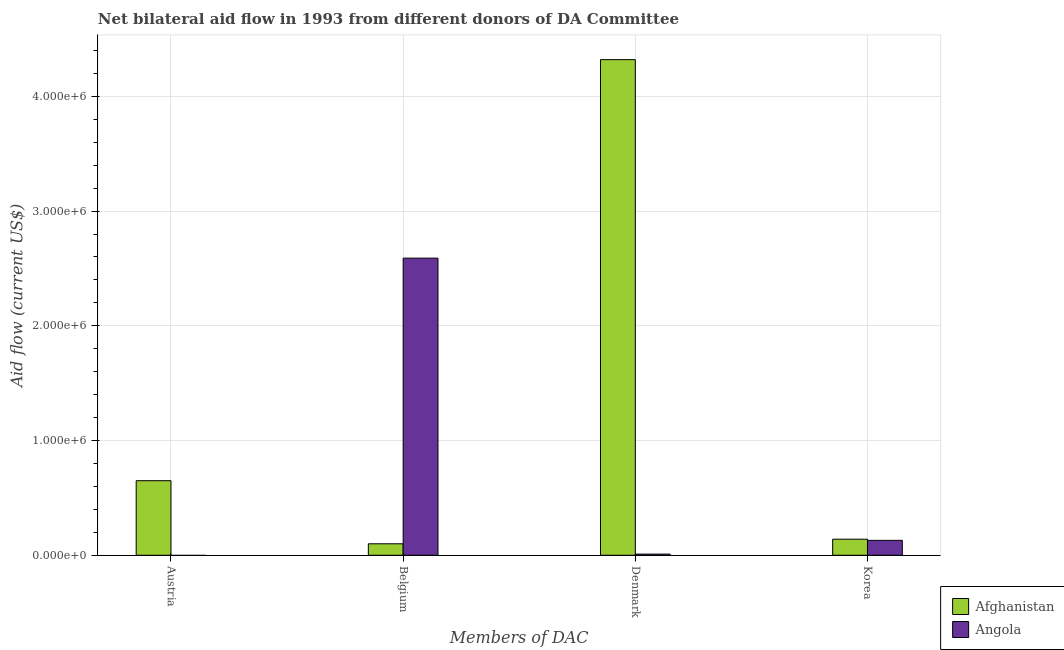How many different coloured bars are there?
Give a very brief answer. 2. Are the number of bars per tick equal to the number of legend labels?
Your answer should be very brief. No. How many bars are there on the 2nd tick from the right?
Offer a very short reply. 2. What is the label of the 3rd group of bars from the left?
Your answer should be compact. Denmark. What is the amount of aid given by belgium in Afghanistan?
Keep it short and to the point. 1.00e+05. Across all countries, what is the maximum amount of aid given by korea?
Provide a short and direct response. 1.40e+05. Across all countries, what is the minimum amount of aid given by belgium?
Make the answer very short. 1.00e+05. In which country was the amount of aid given by austria maximum?
Offer a terse response. Afghanistan. What is the total amount of aid given by belgium in the graph?
Provide a succinct answer. 2.69e+06. What is the difference between the amount of aid given by denmark in Angola and that in Afghanistan?
Your answer should be compact. -4.31e+06. What is the difference between the amount of aid given by denmark in Angola and the amount of aid given by belgium in Afghanistan?
Make the answer very short. -9.00e+04. What is the average amount of aid given by korea per country?
Offer a very short reply. 1.35e+05. What is the difference between the amount of aid given by belgium and amount of aid given by korea in Afghanistan?
Provide a short and direct response. -4.00e+04. What is the ratio of the amount of aid given by belgium in Afghanistan to that in Angola?
Offer a very short reply. 0.04. What is the difference between the highest and the second highest amount of aid given by denmark?
Ensure brevity in your answer.  4.31e+06. What is the difference between the highest and the lowest amount of aid given by denmark?
Offer a very short reply. 4.31e+06. In how many countries, is the amount of aid given by korea greater than the average amount of aid given by korea taken over all countries?
Offer a very short reply. 1. Is the sum of the amount of aid given by korea in Afghanistan and Angola greater than the maximum amount of aid given by belgium across all countries?
Provide a short and direct response. No. Is it the case that in every country, the sum of the amount of aid given by austria and amount of aid given by belgium is greater than the amount of aid given by denmark?
Your answer should be very brief. No. How many bars are there?
Your answer should be compact. 7. Are all the bars in the graph horizontal?
Your answer should be very brief. No. Does the graph contain grids?
Your answer should be very brief. Yes. Where does the legend appear in the graph?
Offer a very short reply. Bottom right. How many legend labels are there?
Give a very brief answer. 2. How are the legend labels stacked?
Your answer should be compact. Vertical. What is the title of the graph?
Give a very brief answer. Net bilateral aid flow in 1993 from different donors of DA Committee. Does "West Bank and Gaza" appear as one of the legend labels in the graph?
Provide a short and direct response. No. What is the label or title of the X-axis?
Make the answer very short. Members of DAC. What is the Aid flow (current US$) of Afghanistan in Austria?
Ensure brevity in your answer.  6.50e+05. What is the Aid flow (current US$) in Angola in Belgium?
Provide a succinct answer. 2.59e+06. What is the Aid flow (current US$) in Afghanistan in Denmark?
Provide a succinct answer. 4.32e+06. What is the Aid flow (current US$) of Angola in Denmark?
Offer a terse response. 10000. What is the Aid flow (current US$) in Afghanistan in Korea?
Provide a succinct answer. 1.40e+05. What is the Aid flow (current US$) of Angola in Korea?
Ensure brevity in your answer.  1.30e+05. Across all Members of DAC, what is the maximum Aid flow (current US$) of Afghanistan?
Offer a very short reply. 4.32e+06. Across all Members of DAC, what is the maximum Aid flow (current US$) of Angola?
Offer a very short reply. 2.59e+06. Across all Members of DAC, what is the minimum Aid flow (current US$) of Afghanistan?
Ensure brevity in your answer.  1.00e+05. Across all Members of DAC, what is the minimum Aid flow (current US$) of Angola?
Give a very brief answer. 0. What is the total Aid flow (current US$) of Afghanistan in the graph?
Offer a terse response. 5.21e+06. What is the total Aid flow (current US$) in Angola in the graph?
Your response must be concise. 2.73e+06. What is the difference between the Aid flow (current US$) of Afghanistan in Austria and that in Denmark?
Your answer should be compact. -3.67e+06. What is the difference between the Aid flow (current US$) in Afghanistan in Austria and that in Korea?
Your answer should be very brief. 5.10e+05. What is the difference between the Aid flow (current US$) in Afghanistan in Belgium and that in Denmark?
Offer a very short reply. -4.22e+06. What is the difference between the Aid flow (current US$) in Angola in Belgium and that in Denmark?
Your answer should be compact. 2.58e+06. What is the difference between the Aid flow (current US$) of Afghanistan in Belgium and that in Korea?
Your answer should be very brief. -4.00e+04. What is the difference between the Aid flow (current US$) in Angola in Belgium and that in Korea?
Give a very brief answer. 2.46e+06. What is the difference between the Aid flow (current US$) in Afghanistan in Denmark and that in Korea?
Keep it short and to the point. 4.18e+06. What is the difference between the Aid flow (current US$) of Afghanistan in Austria and the Aid flow (current US$) of Angola in Belgium?
Your answer should be very brief. -1.94e+06. What is the difference between the Aid flow (current US$) of Afghanistan in Austria and the Aid flow (current US$) of Angola in Denmark?
Offer a terse response. 6.40e+05. What is the difference between the Aid flow (current US$) of Afghanistan in Austria and the Aid flow (current US$) of Angola in Korea?
Make the answer very short. 5.20e+05. What is the difference between the Aid flow (current US$) in Afghanistan in Denmark and the Aid flow (current US$) in Angola in Korea?
Keep it short and to the point. 4.19e+06. What is the average Aid flow (current US$) of Afghanistan per Members of DAC?
Your answer should be compact. 1.30e+06. What is the average Aid flow (current US$) of Angola per Members of DAC?
Offer a terse response. 6.82e+05. What is the difference between the Aid flow (current US$) in Afghanistan and Aid flow (current US$) in Angola in Belgium?
Make the answer very short. -2.49e+06. What is the difference between the Aid flow (current US$) of Afghanistan and Aid flow (current US$) of Angola in Denmark?
Offer a terse response. 4.31e+06. What is the difference between the Aid flow (current US$) in Afghanistan and Aid flow (current US$) in Angola in Korea?
Your response must be concise. 10000. What is the ratio of the Aid flow (current US$) in Afghanistan in Austria to that in Belgium?
Your response must be concise. 6.5. What is the ratio of the Aid flow (current US$) of Afghanistan in Austria to that in Denmark?
Give a very brief answer. 0.15. What is the ratio of the Aid flow (current US$) of Afghanistan in Austria to that in Korea?
Your response must be concise. 4.64. What is the ratio of the Aid flow (current US$) in Afghanistan in Belgium to that in Denmark?
Make the answer very short. 0.02. What is the ratio of the Aid flow (current US$) in Angola in Belgium to that in Denmark?
Ensure brevity in your answer.  259. What is the ratio of the Aid flow (current US$) in Afghanistan in Belgium to that in Korea?
Ensure brevity in your answer.  0.71. What is the ratio of the Aid flow (current US$) in Angola in Belgium to that in Korea?
Your answer should be very brief. 19.92. What is the ratio of the Aid flow (current US$) in Afghanistan in Denmark to that in Korea?
Give a very brief answer. 30.86. What is the ratio of the Aid flow (current US$) in Angola in Denmark to that in Korea?
Your answer should be compact. 0.08. What is the difference between the highest and the second highest Aid flow (current US$) of Afghanistan?
Your response must be concise. 3.67e+06. What is the difference between the highest and the second highest Aid flow (current US$) in Angola?
Offer a very short reply. 2.46e+06. What is the difference between the highest and the lowest Aid flow (current US$) in Afghanistan?
Ensure brevity in your answer.  4.22e+06. What is the difference between the highest and the lowest Aid flow (current US$) in Angola?
Offer a terse response. 2.59e+06. 